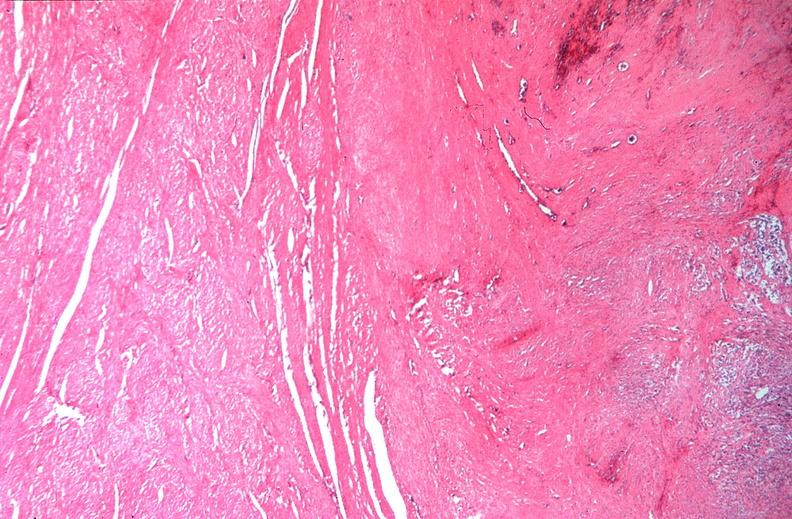does this image show uterus, leiomyomas?
Answer the question using a single word or phrase. Yes 